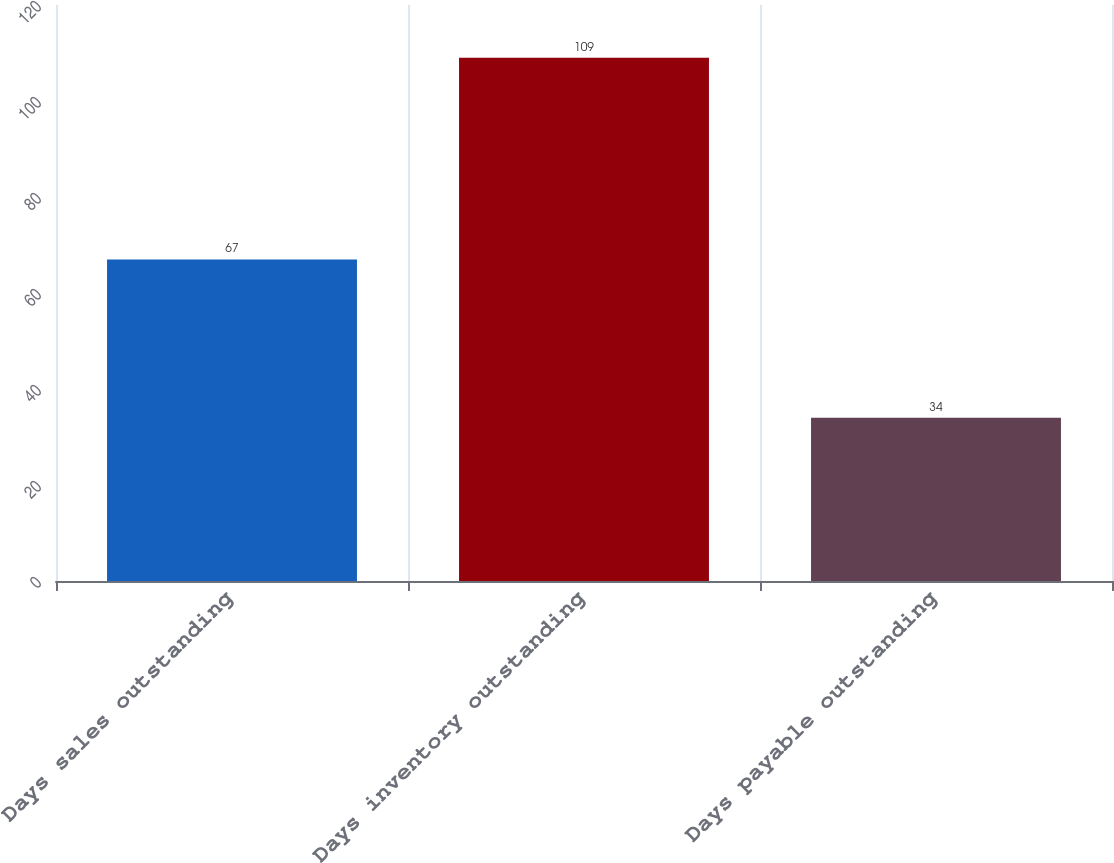Convert chart to OTSL. <chart><loc_0><loc_0><loc_500><loc_500><bar_chart><fcel>Days sales outstanding<fcel>Days inventory outstanding<fcel>Days payable outstanding<nl><fcel>67<fcel>109<fcel>34<nl></chart> 